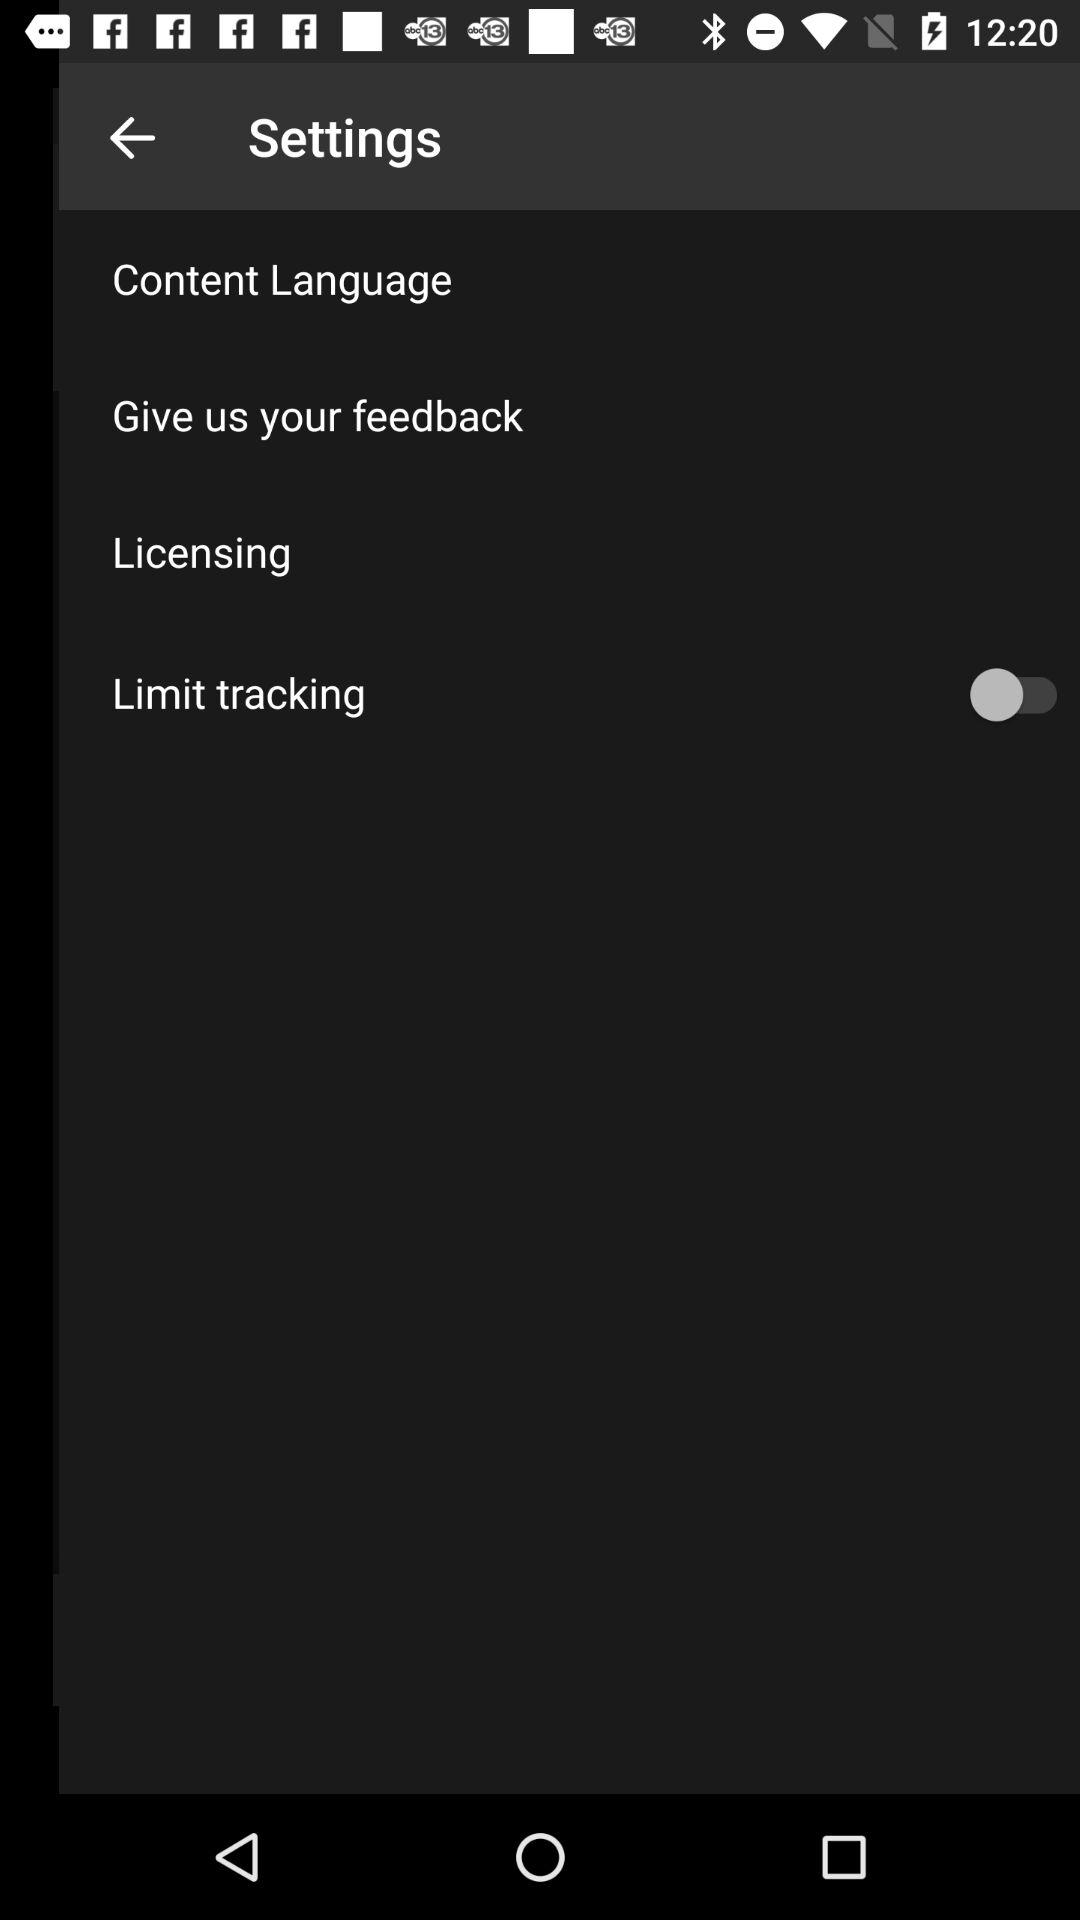What is the status of "Limit tracking"? The status is "off". 